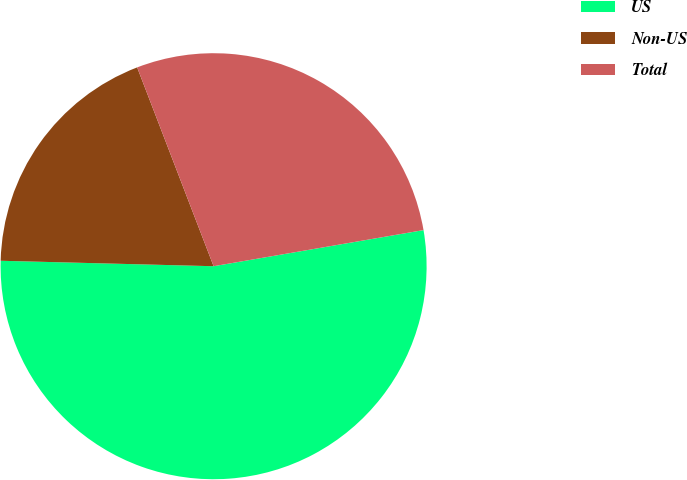Convert chart to OTSL. <chart><loc_0><loc_0><loc_500><loc_500><pie_chart><fcel>US<fcel>Non-US<fcel>Total<nl><fcel>53.12%<fcel>18.75%<fcel>28.13%<nl></chart> 